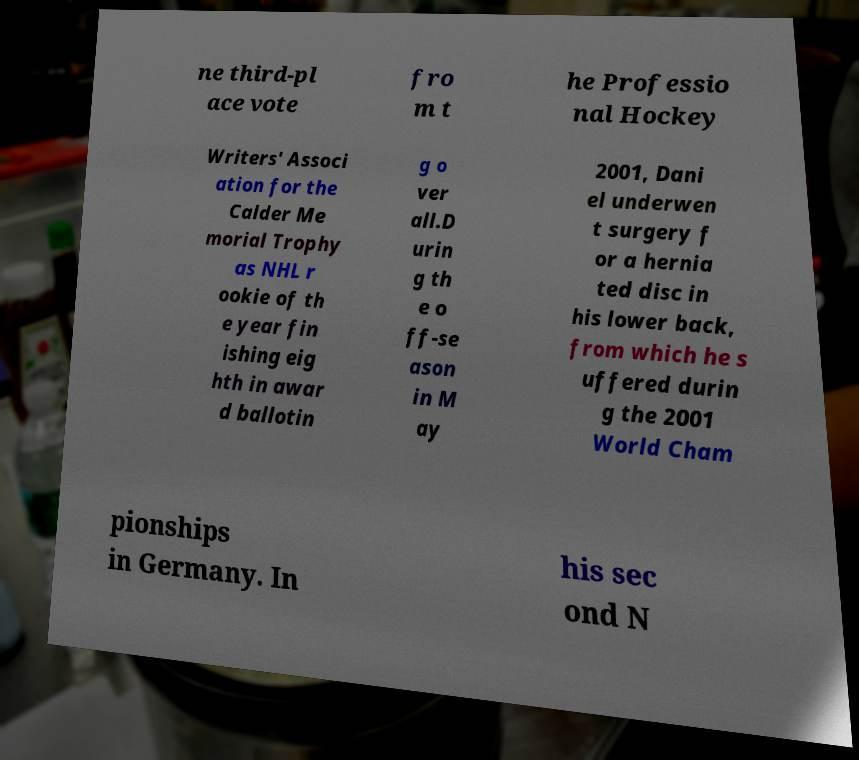There's text embedded in this image that I need extracted. Can you transcribe it verbatim? ne third-pl ace vote fro m t he Professio nal Hockey Writers' Associ ation for the Calder Me morial Trophy as NHL r ookie of th e year fin ishing eig hth in awar d ballotin g o ver all.D urin g th e o ff-se ason in M ay 2001, Dani el underwen t surgery f or a hernia ted disc in his lower back, from which he s uffered durin g the 2001 World Cham pionships in Germany. In his sec ond N 